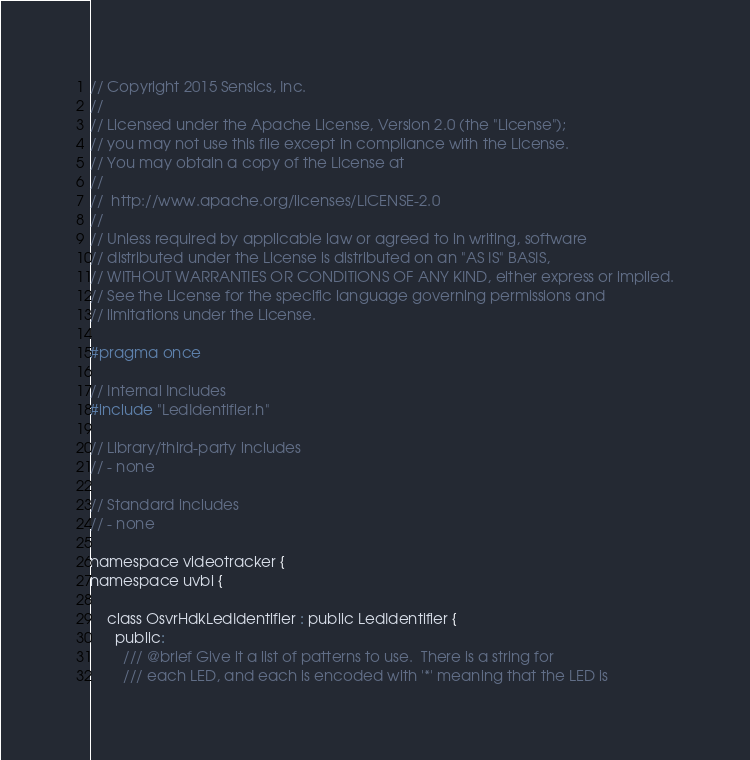<code> <loc_0><loc_0><loc_500><loc_500><_C_>
// Copyright 2015 Sensics, Inc.
//
// Licensed under the Apache License, Version 2.0 (the "License");
// you may not use this file except in compliance with the License.
// You may obtain a copy of the License at
//
// 	http://www.apache.org/licenses/LICENSE-2.0
//
// Unless required by applicable law or agreed to in writing, software
// distributed under the License is distributed on an "AS IS" BASIS,
// WITHOUT WARRANTIES OR CONDITIONS OF ANY KIND, either express or implied.
// See the License for the specific language governing permissions and
// limitations under the License.

#pragma once

// Internal Includes
#include "LedIdentifier.h"

// Library/third-party includes
// - none

// Standard includes
// - none

namespace videotracker {
namespace uvbi {

    class OsvrHdkLedIdentifier : public LedIdentifier {
      public:
        /// @brief Give it a list of patterns to use.  There is a string for
        /// each LED, and each is encoded with '*' meaning that the LED is</code> 